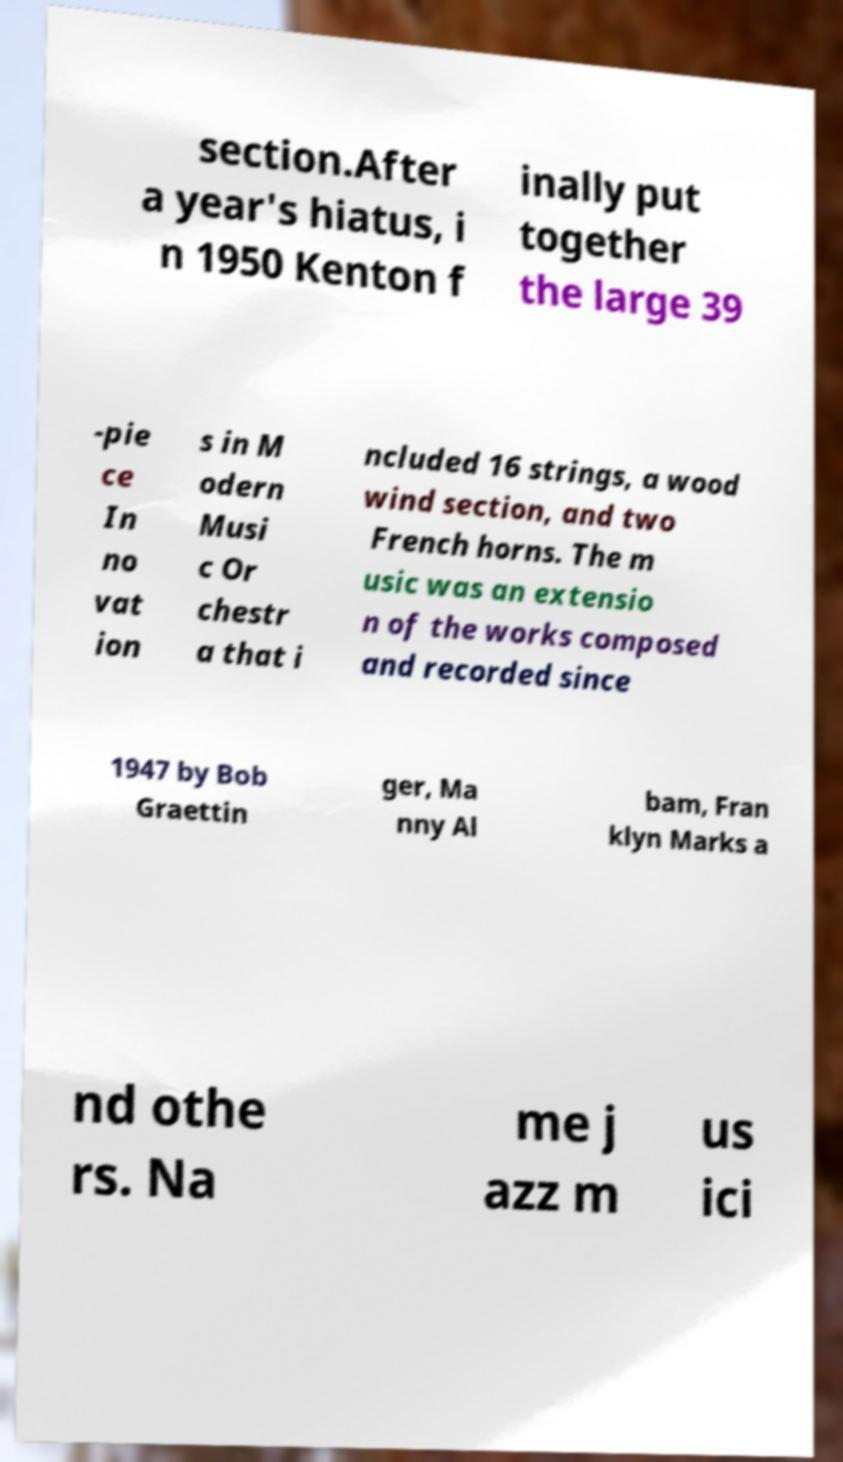Please read and relay the text visible in this image. What does it say? section.After a year's hiatus, i n 1950 Kenton f inally put together the large 39 -pie ce In no vat ion s in M odern Musi c Or chestr a that i ncluded 16 strings, a wood wind section, and two French horns. The m usic was an extensio n of the works composed and recorded since 1947 by Bob Graettin ger, Ma nny Al bam, Fran klyn Marks a nd othe rs. Na me j azz m us ici 